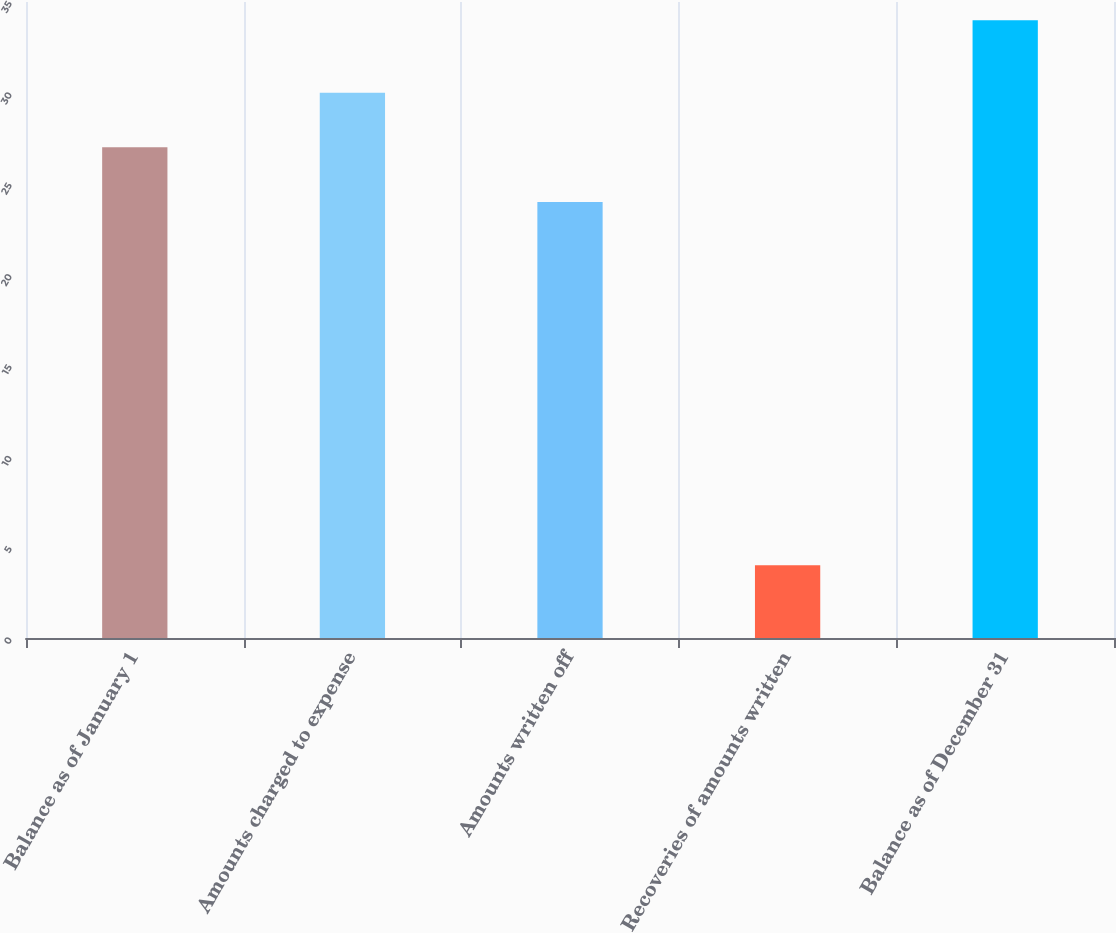Convert chart to OTSL. <chart><loc_0><loc_0><loc_500><loc_500><bar_chart><fcel>Balance as of January 1<fcel>Amounts charged to expense<fcel>Amounts written off<fcel>Recoveries of amounts written<fcel>Balance as of December 31<nl><fcel>27<fcel>30<fcel>24<fcel>4<fcel>34<nl></chart> 